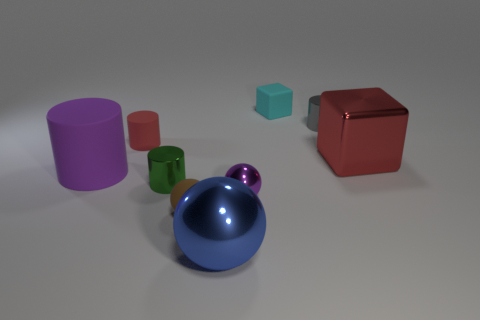What lighting conditions are suggested by the shadows in the image? The shadows indicate a single light source above the objects, slightly off to the left, creating soft-edged shadows directly opposite the light. Could you guess the time of day if this was outdoors? If this were outdoors, the angle and softness of the shadows could suggest late afternoon when the sun is lower in the sky, casting longer, softer shadows. 